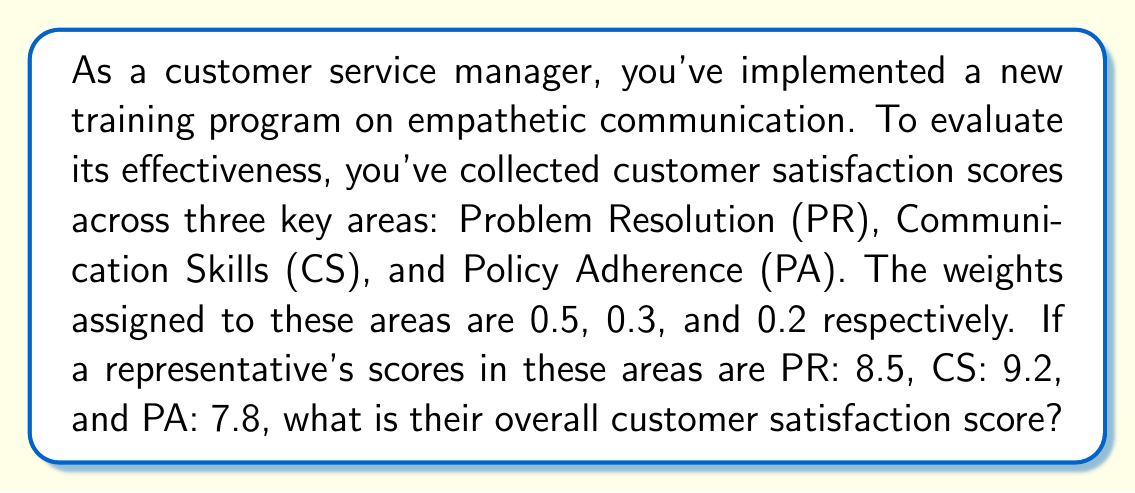Can you answer this question? To calculate the overall customer satisfaction score using weighted averages, we need to follow these steps:

1. Identify the scores and weights for each area:
   - Problem Resolution (PR): Score = 8.5, Weight = 0.5
   - Communication Skills (CS): Score = 9.2, Weight = 0.3
   - Policy Adherence (PA): Score = 7.8, Weight = 0.2

2. Multiply each score by its corresponding weight:
   - PR: $8.5 \times 0.5 = 4.25$
   - CS: $9.2 \times 0.3 = 2.76$
   - PA: $7.8 \times 0.2 = 1.56$

3. Sum up the weighted scores:
   $$\text{Overall Score} = 4.25 + 2.76 + 1.56$$

4. Calculate the final result:
   $$\text{Overall Score} = 8.57$$

The weighted average formula used here is:

$$\text{Weighted Average} = \frac{\sum_{i=1}^{n} w_i x_i}{\sum_{i=1}^{n} w_i}$$

Where $w_i$ are the weights and $x_i$ are the scores.

In this case, the sum of weights is 1 (0.5 + 0.3 + 0.2), so we don't need to divide by the sum of weights.
Answer: The overall customer satisfaction score is 8.57. 